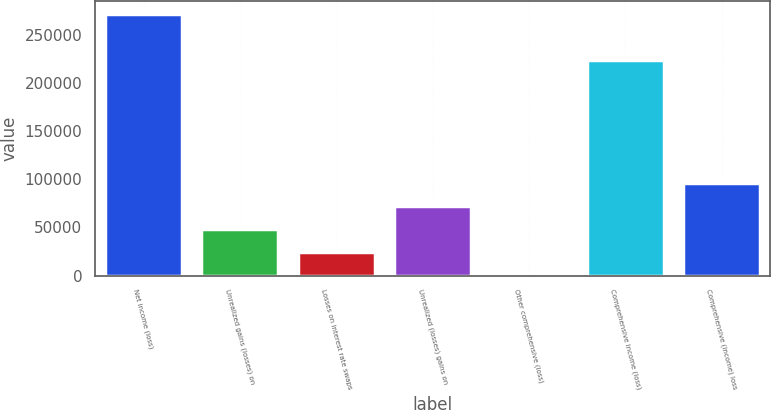Convert chart. <chart><loc_0><loc_0><loc_500><loc_500><bar_chart><fcel>Net income (loss)<fcel>Unrealized gains (losses) on<fcel>Losses on interest rate swaps<fcel>Unrealized (losses) gains on<fcel>Other comprehensive (loss)<fcel>Comprehensive income (loss)<fcel>Comprehensive (income) loss<nl><fcel>271644<fcel>48185.8<fcel>24480.9<fcel>71890.7<fcel>776<fcel>224234<fcel>95595.6<nl></chart> 